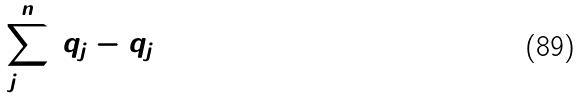<formula> <loc_0><loc_0><loc_500><loc_500>\sum _ { j = 1 } ^ { n } ( q _ { j } - q _ { j + 1 } ) ^ { 2 }</formula> 